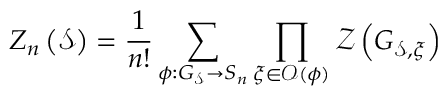<formula> <loc_0><loc_0><loc_500><loc_500>Z _ { n } \left ( \mathcal { S } \right ) = \frac { 1 } { n ! } \sum _ { \phi \colon G _ { \mathcal { S } } \rightarrow S _ { n } } \prod _ { \xi \in \mathcal { O } ( \phi ) } \mathcal { Z } \left ( G _ { \mathcal { S } , \xi } \right )</formula> 